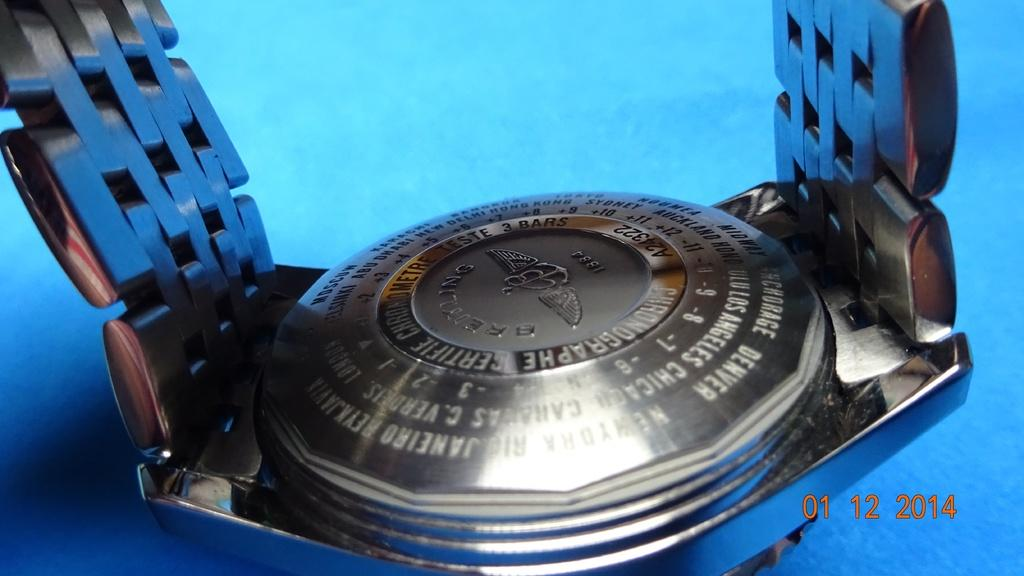Provide a one-sentence caption for the provided image. A Breitling watch sits on its face as the back is shown. 